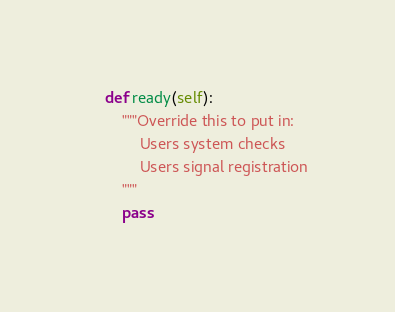Convert code to text. <code><loc_0><loc_0><loc_500><loc_500><_Python_>    def ready(self):
        """Override this to put in:
            Users system checks
            Users signal registration
        """
        pass
</code> 